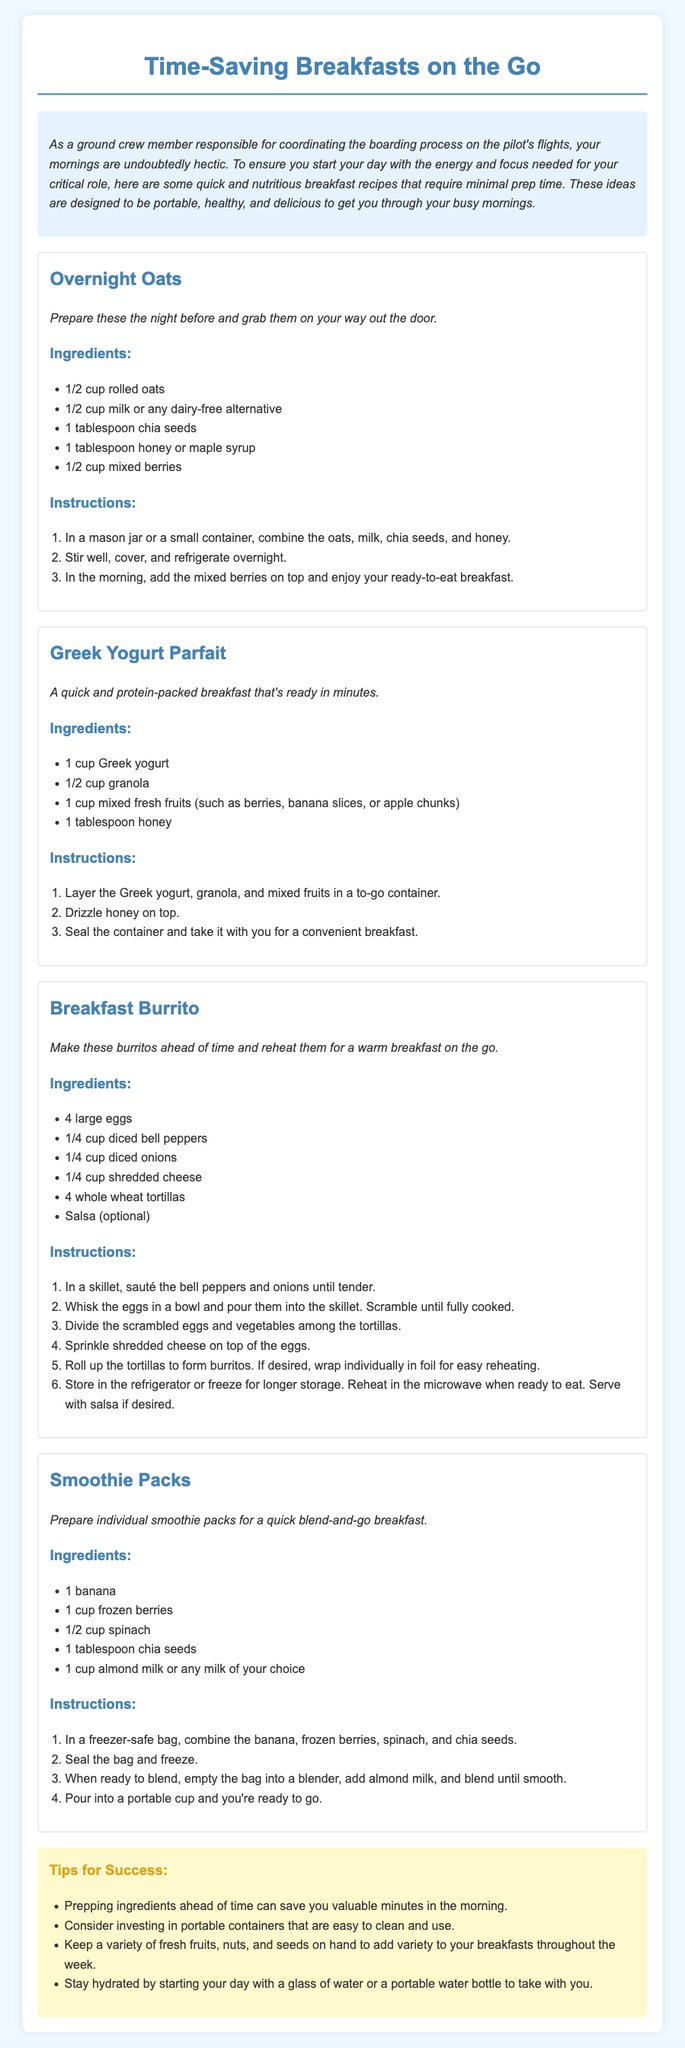What is the first recipe listed? The recipes are given in a specific order, and the first one mentioned is "Overnight Oats."
Answer: Overnight Oats How many eggs are needed for the Breakfast Burrito? The ingredients for the Breakfast Burrito specifically state that 4 large eggs are required.
Answer: 4 What are the three main ingredients in the Greek Yogurt Parfait? The recipe lists Greek yogurt, granola, and mixed fresh fruits as the main ingredients.
Answer: Greek yogurt, granola, mixed fresh fruits What is the purpose of the tips section? The tips section provides advice to enhance the breakfast preparation process and ensure easier execution of the recipes.
Answer: Enhance breakfast preparation How many ingredients are listed for the Smoothie Packs? The ingredients section for the Smoothie Packs includes 5 items mentioned in the list.
Answer: 5 What can you use to sweeten the Overnight Oats? The Overnight Oats recipe mentions honey or maple syrup as sweetening options.
Answer: Honey or maple syrup How should the Breakfast Burritos be stored for later use? The instructions suggest storing the Breakfast Burritos in the refrigerator or freezing for longer storage.
Answer: Refrigerator or freeze What is one benefit of preparing ingredients ahead of time? The document highlights that prepping ingredients can save valuable minutes in the morning.
Answer: Save valuable minutes 